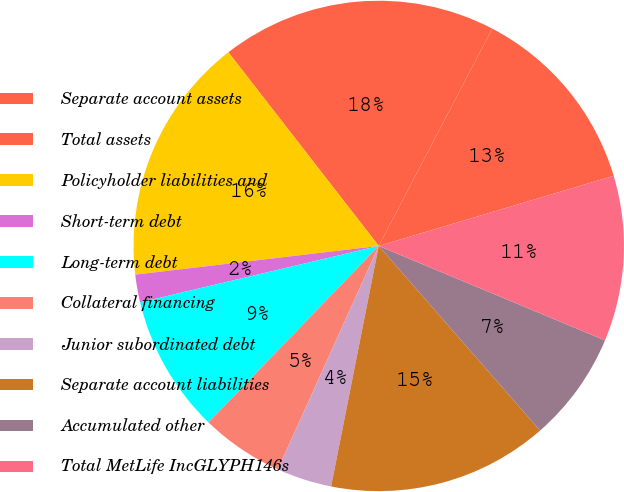<chart> <loc_0><loc_0><loc_500><loc_500><pie_chart><fcel>Separate account assets<fcel>Total assets<fcel>Policyholder liabilities and<fcel>Short-term debt<fcel>Long-term debt<fcel>Collateral financing<fcel>Junior subordinated debt<fcel>Separate account liabilities<fcel>Accumulated other<fcel>Total MetLife IncGLYPH146s<nl><fcel>12.72%<fcel>18.17%<fcel>16.36%<fcel>1.83%<fcel>9.09%<fcel>5.46%<fcel>3.64%<fcel>14.54%<fcel>7.28%<fcel>10.91%<nl></chart> 